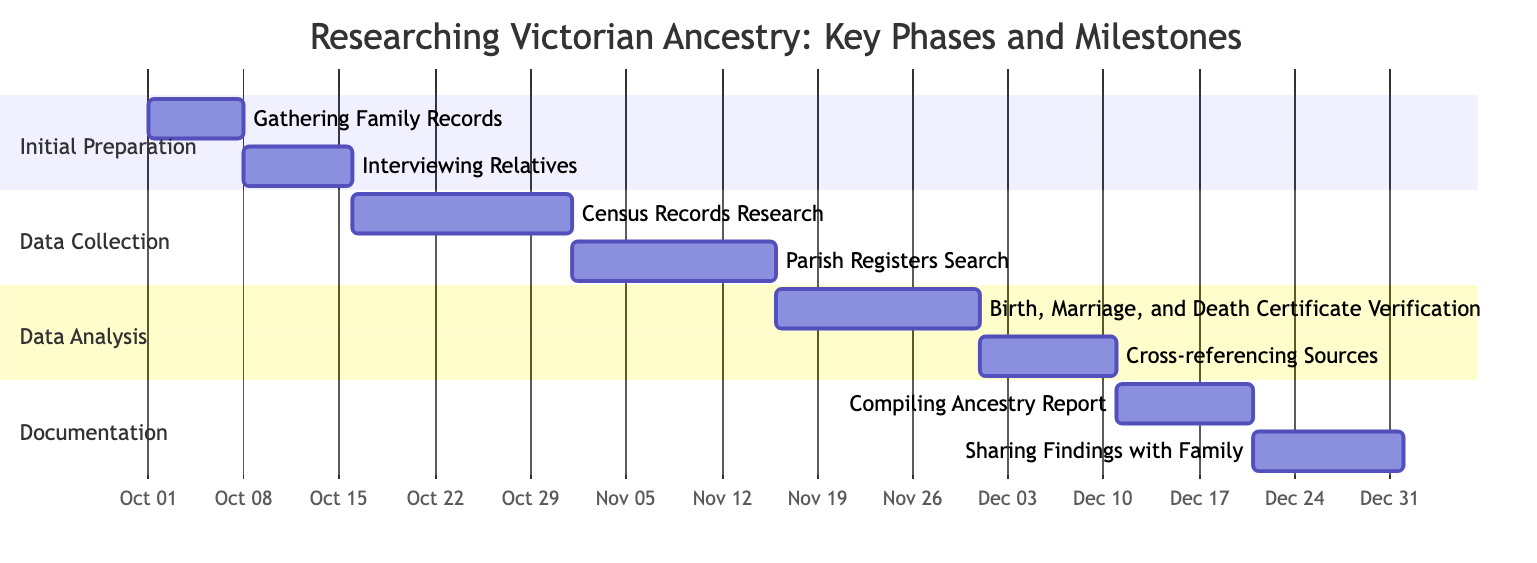What is the duration of the "Initial Preparation" phase? The "Initial Preparation" phase starts on October 1, 2023, and ends on October 15, 2023. The duration is calculated by subtracting the start date from the end date, which is 15 days.
Answer: 15 days Which task overlaps with "Census Records Research"? The "Census Records Research" task starts on October 16, 2023, and ends on October 31, 2023. The "Parish Registers Search" task starts on November 1, 2023, meaning these two tasks do not overlap. The only overlapping task is "Interviewing Relatives," which spans from October 8 to October 15, 2023.
Answer: Interviewing Relatives What is the end date for "Cross-referencing Sources"? The task "Cross-referencing Sources" starts on December 1, 2023, and is scheduled to last for 10 days, which leads to an end date of December 10, 2023.
Answer: December 10, 2023 How many tasks are included in the "Data Collection" phase? Within the "Data Collection" phase, there are two tasks listed: "Census Records Research" and "Parish Registers Search." Counting these provides the answer.
Answer: 2 tasks Which task has the latest start date? By examining all the start dates listed, "Cross-referencing Sources" begins on December 1, 2023, while the others start earlier. Thus, it has the latest start date among all tasks.
Answer: Cross-referencing Sources What day does the "Documentation" phase begin? The "Documentation" phase is shown to start on December 11, 2023, as indicated in the diagram. This is the initial day of this phase, clearly marked.
Answer: December 11, 2023 What is the total number of phases depicted in the diagram? The diagram outlines four distinct phases: "Initial Preparation," "Data Collection," "Data Analysis," and "Documentation." Counting these phases gives the total number.
Answer: 4 phases Which task has the longest duration? Analyzing the durations of each task, "Birth, Marriage, and Death Certificate Verification" lasts for 15 days, while all other tasks are shorter. Hence, this task has the longest duration.
Answer: Birth, Marriage, and Death Certificate Verification 